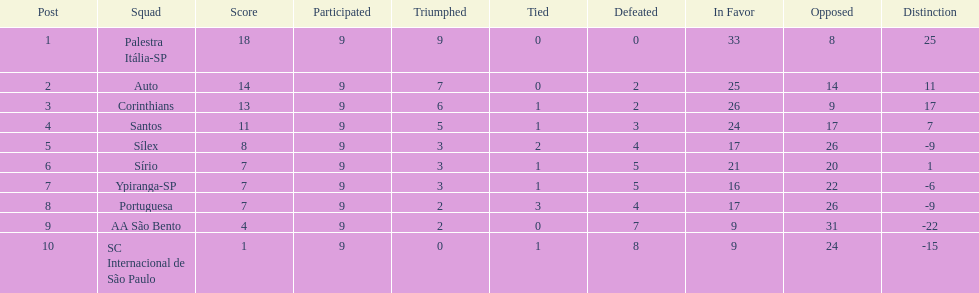Could you parse the entire table? {'header': ['Post', 'Squad', 'Score', 'Participated', 'Triumphed', 'Tied', 'Defeated', 'In Favor', 'Opposed', 'Distinction'], 'rows': [['1', 'Palestra Itália-SP', '18', '9', '9', '0', '0', '33', '8', '25'], ['2', 'Auto', '14', '9', '7', '0', '2', '25', '14', '11'], ['3', 'Corinthians', '13', '9', '6', '1', '2', '26', '9', '17'], ['4', 'Santos', '11', '9', '5', '1', '3', '24', '17', '7'], ['5', 'Sílex', '8', '9', '3', '2', '4', '17', '26', '-9'], ['6', 'Sírio', '7', '9', '3', '1', '5', '21', '20', '1'], ['7', 'Ypiranga-SP', '7', '9', '3', '1', '5', '16', '22', '-6'], ['8', 'Portuguesa', '7', '9', '2', '3', '4', '17', '26', '-9'], ['9', 'AA São Bento', '4', '9', '2', '0', '7', '9', '31', '-22'], ['10', 'SC Internacional de São Paulo', '1', '9', '0', '1', '8', '9', '24', '-15']]} How many teams had more points than silex? 4. 